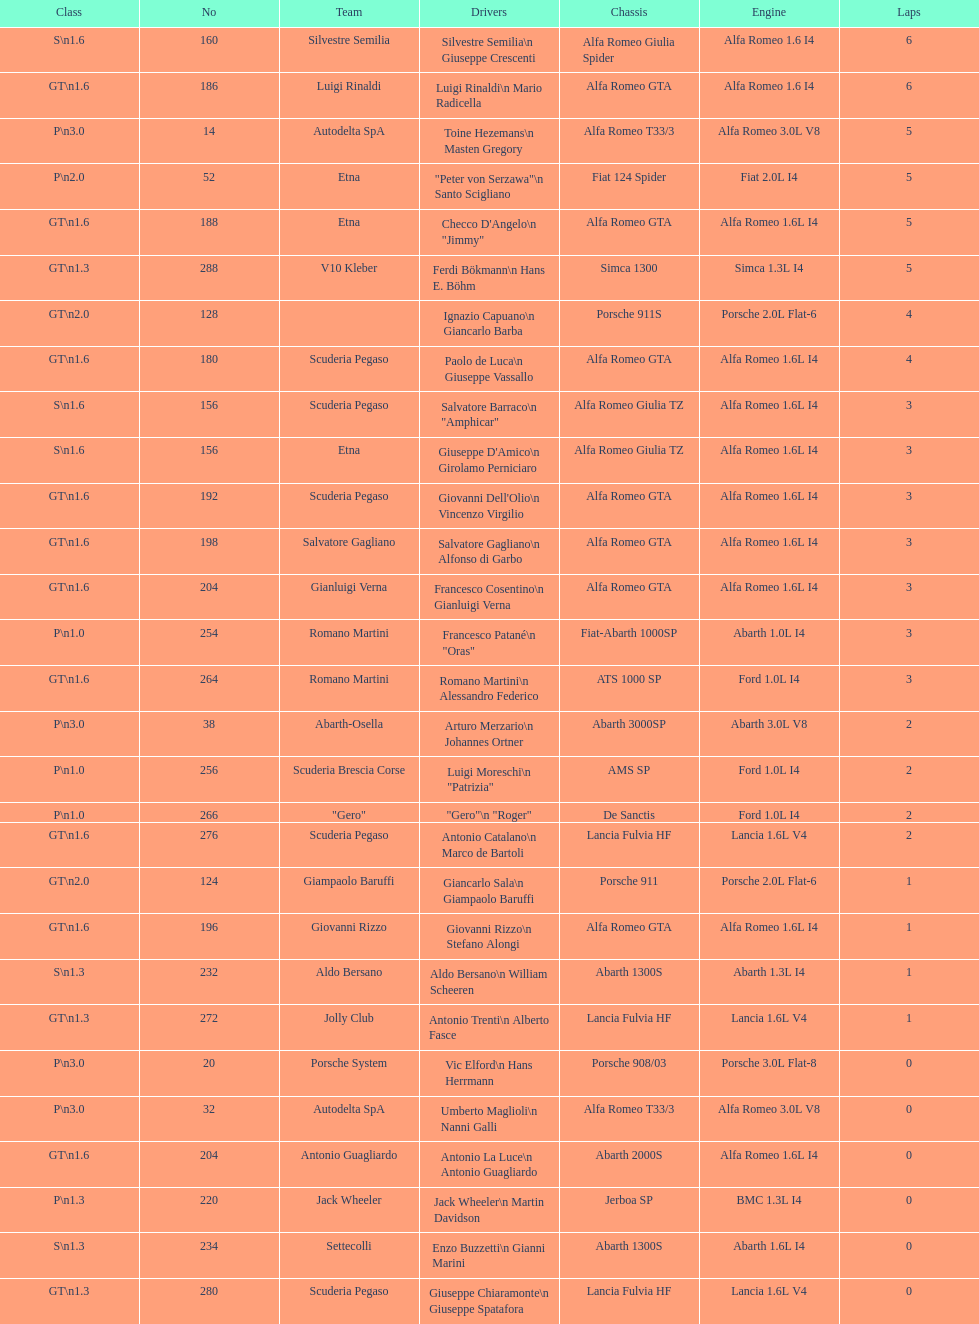How many teams failed to finish the race after 2 laps? 4. 